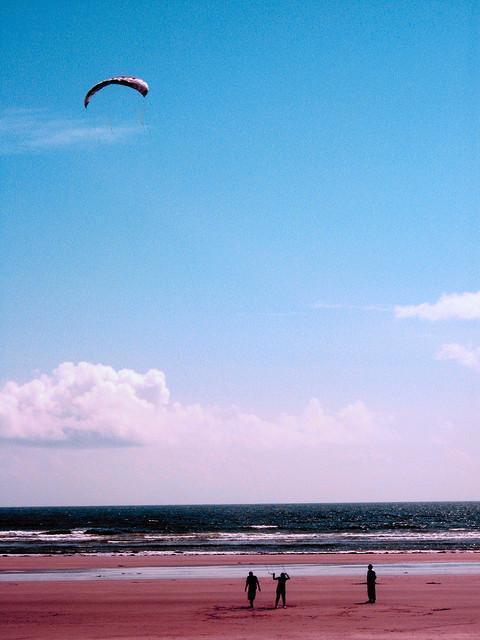How many people are there?
Give a very brief answer. 3. How many dogs are there?
Give a very brief answer. 0. 